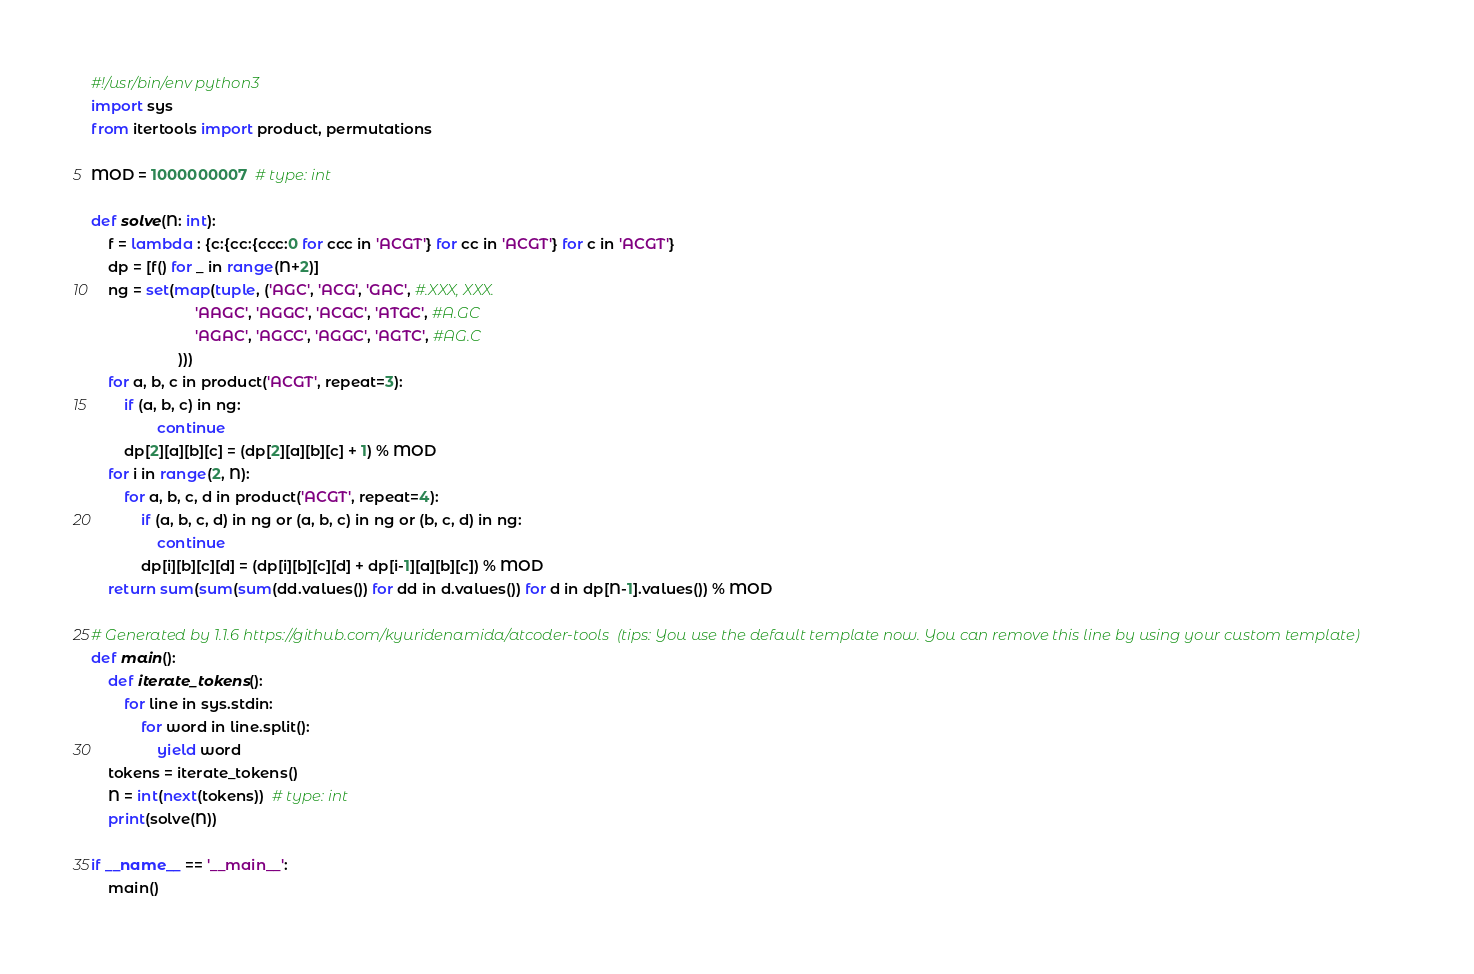Convert code to text. <code><loc_0><loc_0><loc_500><loc_500><_Python_>#!/usr/bin/env python3
import sys
from itertools import product, permutations

MOD = 1000000007  # type: int

def solve(N: int):
    f = lambda : {c:{cc:{ccc:0 for ccc in 'ACGT'} for cc in 'ACGT'} for c in 'ACGT'}
    dp = [f() for _ in range(N+2)]
    ng = set(map(tuple, ('AGC', 'ACG', 'GAC', #.XXX, XXX.
                         'AAGC', 'AGGC', 'ACGC', 'ATGC', #A.GC
                         'AGAC', 'AGCC', 'AGGC', 'AGTC', #AG.C
                     )))
    for a, b, c in product('ACGT', repeat=3):
        if (a, b, c) in ng:
                continue
        dp[2][a][b][c] = (dp[2][a][b][c] + 1) % MOD
    for i in range(2, N):
        for a, b, c, d in product('ACGT', repeat=4):
            if (a, b, c, d) in ng or (a, b, c) in ng or (b, c, d) in ng:
                continue
            dp[i][b][c][d] = (dp[i][b][c][d] + dp[i-1][a][b][c]) % MOD
    return sum(sum(sum(dd.values()) for dd in d.values()) for d in dp[N-1].values()) % MOD

# Generated by 1.1.6 https://github.com/kyuridenamida/atcoder-tools  (tips: You use the default template now. You can remove this line by using your custom template)
def main():
    def iterate_tokens():
        for line in sys.stdin:
            for word in line.split():
                yield word
    tokens = iterate_tokens()
    N = int(next(tokens))  # type: int
    print(solve(N))

if __name__ == '__main__':
    main()
</code> 